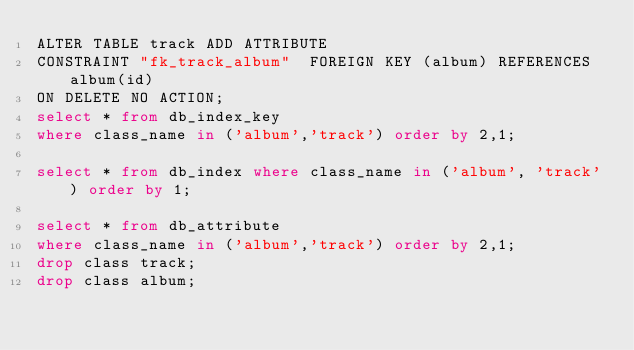<code> <loc_0><loc_0><loc_500><loc_500><_SQL_>ALTER TABLE track ADD ATTRIBUTE
CONSTRAINT "fk_track_album"  FOREIGN KEY (album) REFERENCES album(id)
ON DELETE NO ACTION;
select * from db_index_key
where class_name in ('album','track') order by 2,1;

select * from db_index where class_name in ('album', 'track') order by 1;

select * from db_attribute
where class_name in ('album','track') order by 2,1;
drop class track;
drop class album;
</code> 